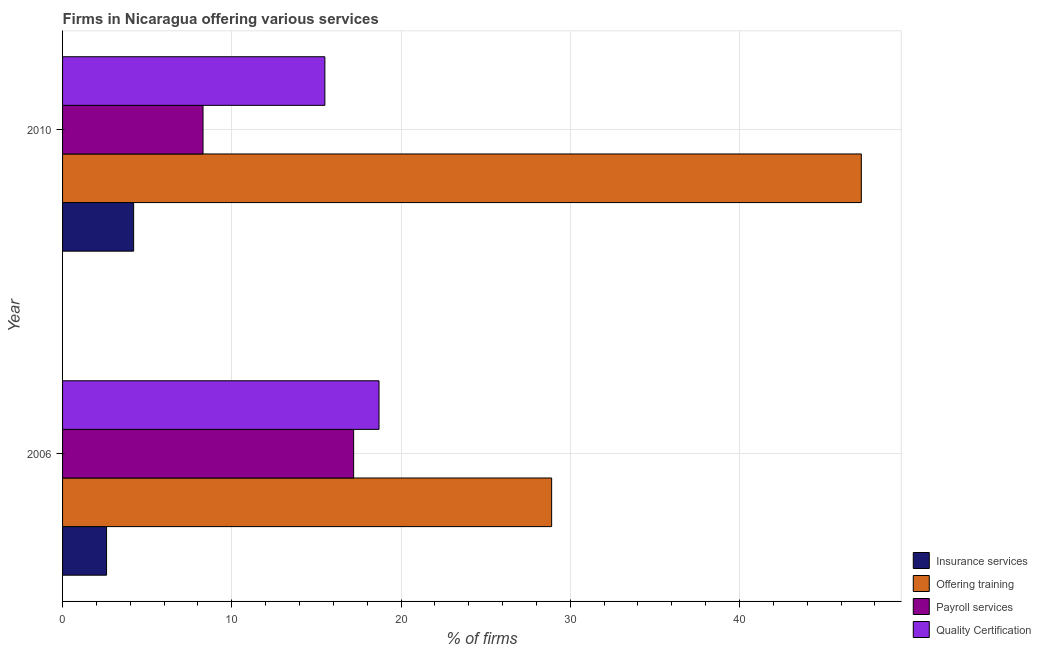How many groups of bars are there?
Make the answer very short. 2. Are the number of bars per tick equal to the number of legend labels?
Make the answer very short. Yes. How many bars are there on the 1st tick from the bottom?
Keep it short and to the point. 4. What is the label of the 2nd group of bars from the top?
Give a very brief answer. 2006. What is the percentage of firms offering training in 2010?
Ensure brevity in your answer.  47.2. Across all years, what is the minimum percentage of firms offering quality certification?
Your answer should be very brief. 15.5. What is the total percentage of firms offering quality certification in the graph?
Your answer should be very brief. 34.2. What is the difference between the percentage of firms offering payroll services in 2010 and the percentage of firms offering training in 2006?
Offer a terse response. -20.6. What is the average percentage of firms offering training per year?
Your answer should be compact. 38.05. In how many years, is the percentage of firms offering quality certification greater than 24 %?
Provide a short and direct response. 0. What is the ratio of the percentage of firms offering quality certification in 2006 to that in 2010?
Provide a succinct answer. 1.21. Is the percentage of firms offering quality certification in 2006 less than that in 2010?
Provide a short and direct response. No. What does the 1st bar from the top in 2006 represents?
Make the answer very short. Quality Certification. What does the 1st bar from the bottom in 2006 represents?
Keep it short and to the point. Insurance services. Is it the case that in every year, the sum of the percentage of firms offering insurance services and percentage of firms offering training is greater than the percentage of firms offering payroll services?
Make the answer very short. Yes. How many bars are there?
Your response must be concise. 8. Are all the bars in the graph horizontal?
Your answer should be compact. Yes. Are the values on the major ticks of X-axis written in scientific E-notation?
Offer a terse response. No. Does the graph contain any zero values?
Make the answer very short. No. Does the graph contain grids?
Your answer should be very brief. Yes. Where does the legend appear in the graph?
Ensure brevity in your answer.  Bottom right. How many legend labels are there?
Offer a very short reply. 4. What is the title of the graph?
Offer a very short reply. Firms in Nicaragua offering various services . What is the label or title of the X-axis?
Keep it short and to the point. % of firms. What is the % of firms in Offering training in 2006?
Ensure brevity in your answer.  28.9. What is the % of firms of Payroll services in 2006?
Give a very brief answer. 17.2. What is the % of firms of Quality Certification in 2006?
Your response must be concise. 18.7. What is the % of firms of Insurance services in 2010?
Offer a very short reply. 4.2. What is the % of firms of Offering training in 2010?
Give a very brief answer. 47.2. What is the % of firms in Payroll services in 2010?
Offer a terse response. 8.3. Across all years, what is the maximum % of firms in Offering training?
Offer a very short reply. 47.2. Across all years, what is the minimum % of firms of Insurance services?
Give a very brief answer. 2.6. Across all years, what is the minimum % of firms of Offering training?
Your response must be concise. 28.9. What is the total % of firms of Offering training in the graph?
Make the answer very short. 76.1. What is the total % of firms of Quality Certification in the graph?
Your response must be concise. 34.2. What is the difference between the % of firms of Insurance services in 2006 and that in 2010?
Ensure brevity in your answer.  -1.6. What is the difference between the % of firms in Offering training in 2006 and that in 2010?
Offer a very short reply. -18.3. What is the difference between the % of firms in Payroll services in 2006 and that in 2010?
Make the answer very short. 8.9. What is the difference between the % of firms in Insurance services in 2006 and the % of firms in Offering training in 2010?
Your response must be concise. -44.6. What is the difference between the % of firms in Insurance services in 2006 and the % of firms in Payroll services in 2010?
Make the answer very short. -5.7. What is the difference between the % of firms in Offering training in 2006 and the % of firms in Payroll services in 2010?
Make the answer very short. 20.6. What is the difference between the % of firms in Offering training in 2006 and the % of firms in Quality Certification in 2010?
Offer a terse response. 13.4. What is the average % of firms in Insurance services per year?
Keep it short and to the point. 3.4. What is the average % of firms of Offering training per year?
Give a very brief answer. 38.05. What is the average % of firms of Payroll services per year?
Your response must be concise. 12.75. In the year 2006, what is the difference between the % of firms in Insurance services and % of firms in Offering training?
Ensure brevity in your answer.  -26.3. In the year 2006, what is the difference between the % of firms in Insurance services and % of firms in Payroll services?
Provide a short and direct response. -14.6. In the year 2006, what is the difference between the % of firms of Insurance services and % of firms of Quality Certification?
Ensure brevity in your answer.  -16.1. In the year 2006, what is the difference between the % of firms in Offering training and % of firms in Payroll services?
Ensure brevity in your answer.  11.7. In the year 2010, what is the difference between the % of firms in Insurance services and % of firms in Offering training?
Keep it short and to the point. -43. In the year 2010, what is the difference between the % of firms of Insurance services and % of firms of Payroll services?
Make the answer very short. -4.1. In the year 2010, what is the difference between the % of firms in Offering training and % of firms in Payroll services?
Offer a terse response. 38.9. In the year 2010, what is the difference between the % of firms of Offering training and % of firms of Quality Certification?
Ensure brevity in your answer.  31.7. What is the ratio of the % of firms in Insurance services in 2006 to that in 2010?
Your answer should be very brief. 0.62. What is the ratio of the % of firms of Offering training in 2006 to that in 2010?
Ensure brevity in your answer.  0.61. What is the ratio of the % of firms of Payroll services in 2006 to that in 2010?
Give a very brief answer. 2.07. What is the ratio of the % of firms in Quality Certification in 2006 to that in 2010?
Keep it short and to the point. 1.21. What is the difference between the highest and the second highest % of firms in Insurance services?
Ensure brevity in your answer.  1.6. What is the difference between the highest and the second highest % of firms in Payroll services?
Your answer should be very brief. 8.9. What is the difference between the highest and the second highest % of firms in Quality Certification?
Keep it short and to the point. 3.2. What is the difference between the highest and the lowest % of firms of Insurance services?
Offer a terse response. 1.6. What is the difference between the highest and the lowest % of firms of Quality Certification?
Provide a succinct answer. 3.2. 